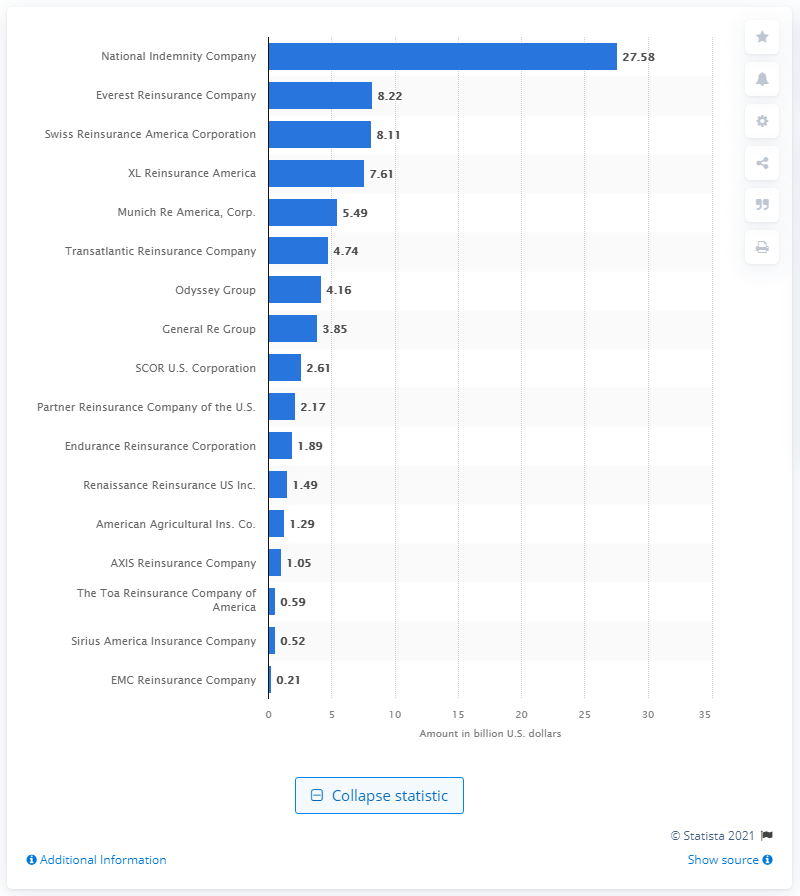Outline some significant characteristics in this image. National Indemnity Company's gross premiums written in dollars amounted to 27.58. National Indemnity Company was the leading reinsurer in the United States as of the fourth quarter of 2020. 